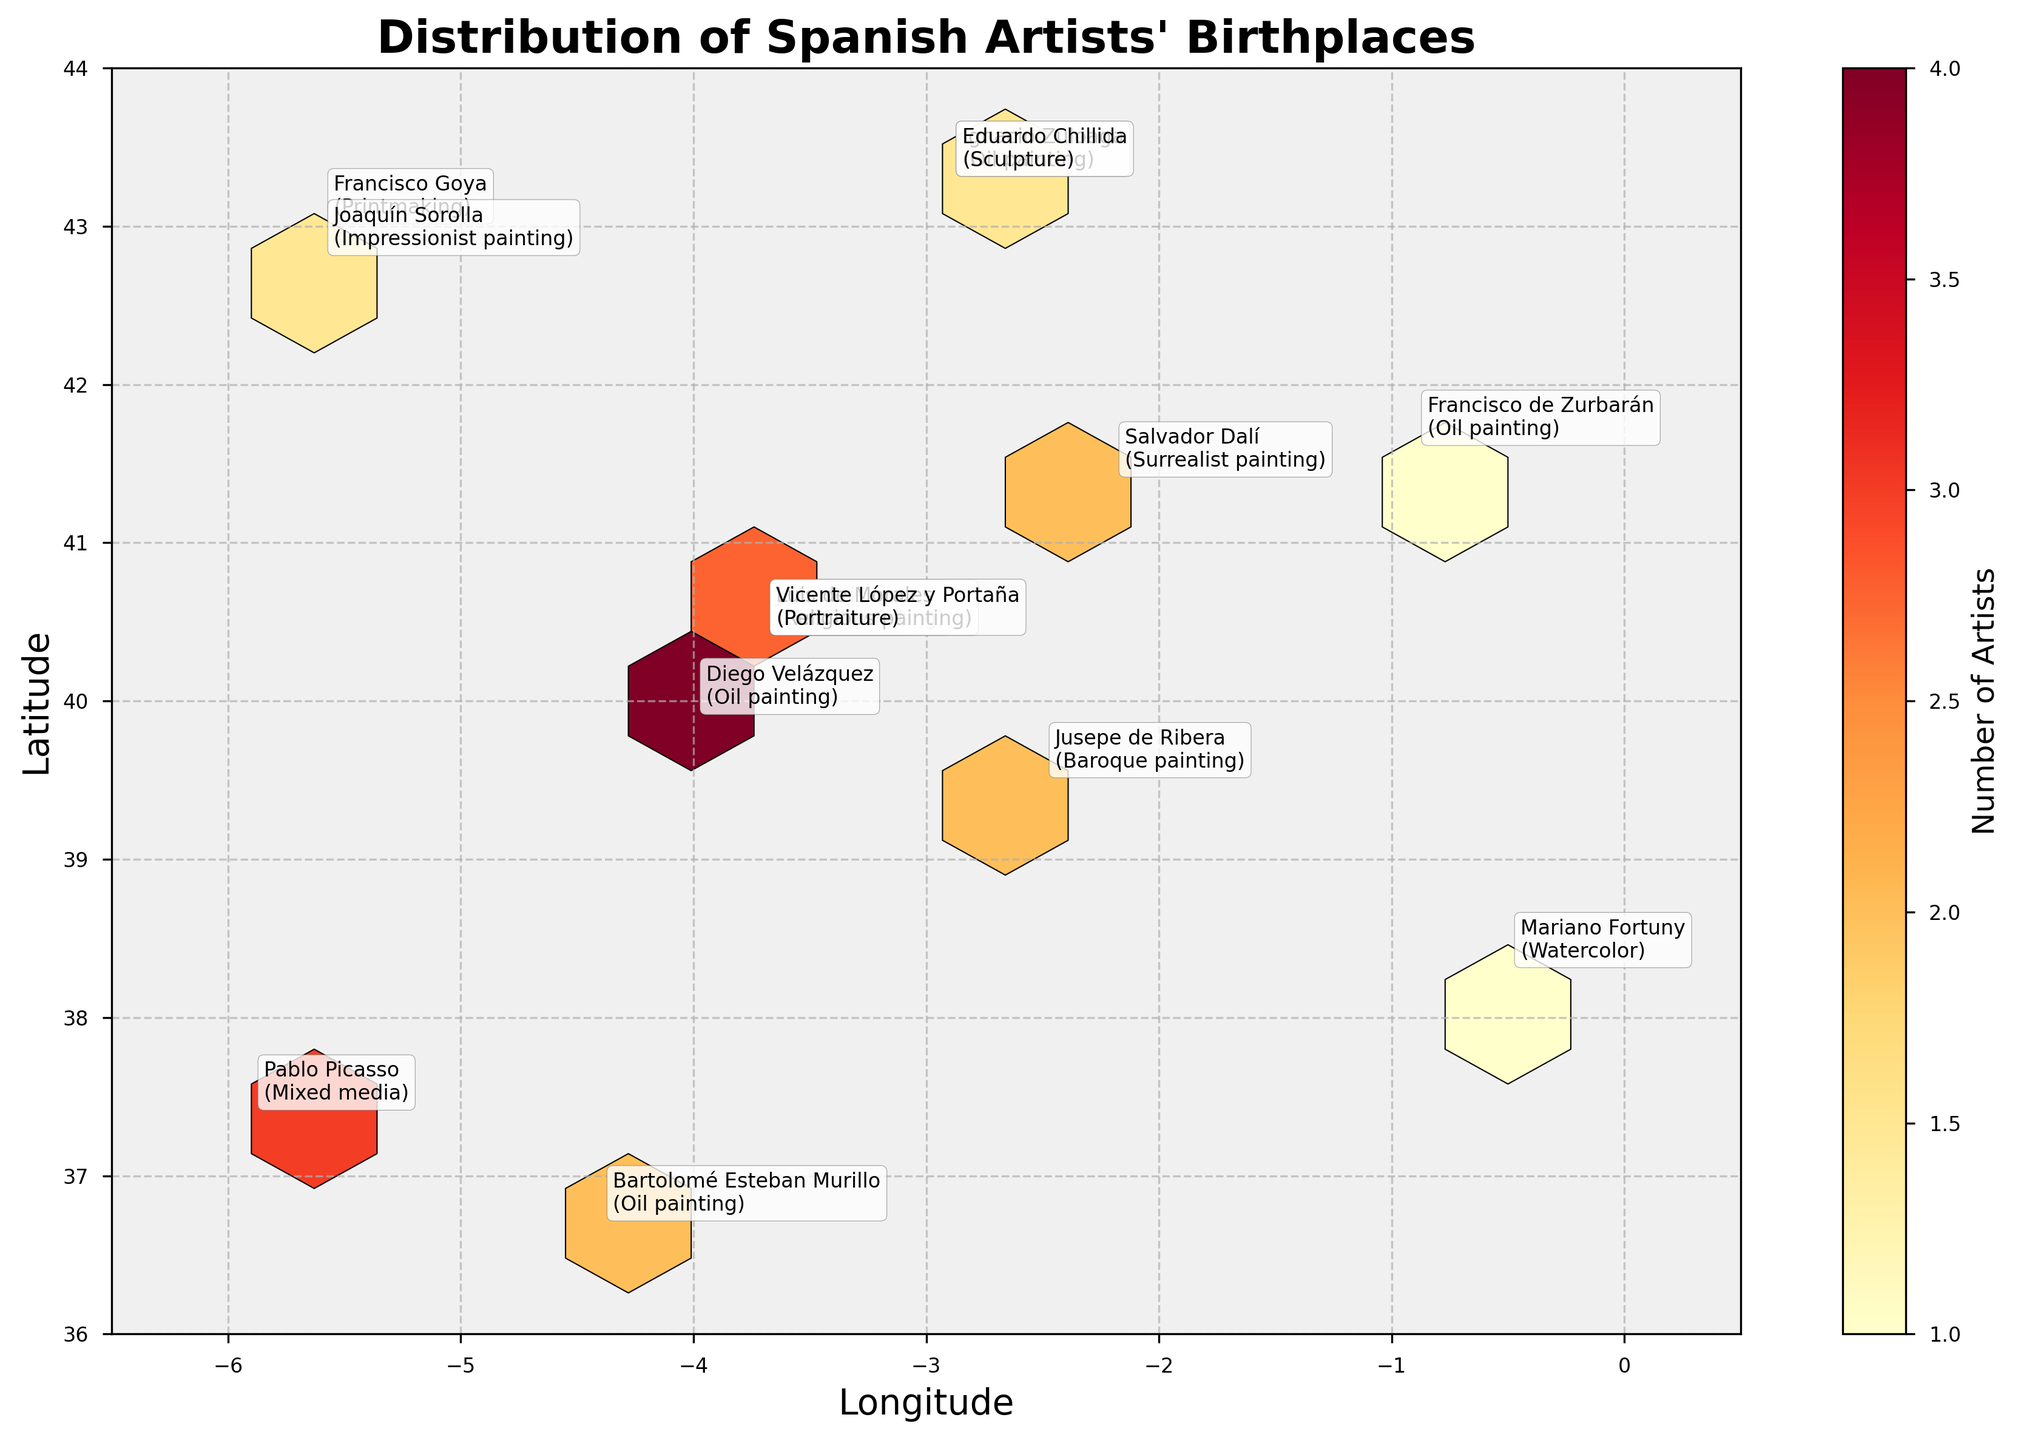How many artists' birthplaces are indicated in the plot? To find this, count the number of annotations in the plot, which show the artists' names and their birthplaces.
Answer: 15 What is the title of the plot? The title is located at the top of the plot, presented in bold, larger font.
Answer: Distribution of Spanish Artists' Birthplaces Which artist has the highest count of birthplaces and what is their count? Look at the hexagons and identify the one with the highest color intensity, then read the count associated with it through annotations or color scale. Here, it is the hex at (-3.7, 40.4) with counts from multiple annotations summing to 3 each for multiple artists, which turns out to be the highest count.
Answer: El Greco, 3 What is the range of latitude values shown in the plot? The latitude range is shown on the y-axis of the plot, from the minimum to maximum values marked.
Answer: 36 to 44 How many artists are associated with oil painting? Identify the annotations that mention "Oil painting" and count them. These are El Greco, Diego Velázquez, Francisco de Zurbarán, Bartolomé Esteban Murillo, and Juan Gris.
Answer: 5 What is the medium preferred by Pablo Picasso? Find the annotation corresponding to Pablo Picasso; his medium is noted next to his name.
Answer: Mixed media Which artists' birthplaces overlap in the same location? Locate annotations placed at the same coordinates. Here, multiple artists are annotated at the coordinates (-3.7, 40.4) including El Greco, Juan Gris, and Vicente López y Portaña.
Answer: El Greco, Juan Gris, Vicente López y Portaña Are there more artists born at latitudes above 40°N or below 40°N? Count the number of annotations above (y > 40) and below (y < 40) the 40°N line. Above 40°N: El Greco, Francisco Goya, Diego Velázquez, Juan Gris, Pablo Picasso, Salvador Dalí, Francisco de Zurbarán, Joaquín Sorolla, Luis de Morales, Ignacio Zuloaga, Eduardo Chillida. Below 40°N: Bartolomé Esteban Murillo, Mariano Fortuny, Jusepe de Ribera.
Answer: Above 40°N What is the color used to indicate the highest artist count on the plot, and what does it represent in terms of artist count? Check the color scale (color bar) and identify the color associated with the highest count value. The color is typically the darkest or most intense on the spectrum used in the hexbin plot.
Answer: Dark red, representing the highest count seen, which is 3 